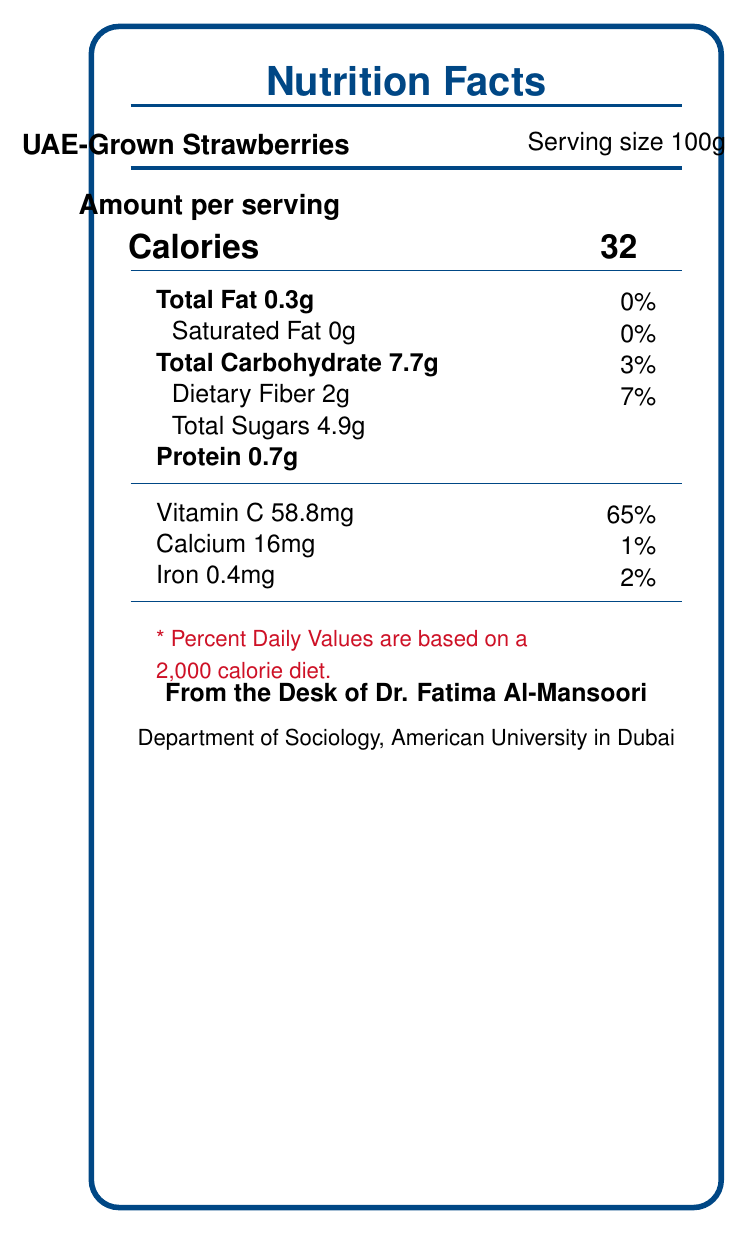what is the serving size for UAE-Grown Strawberries? The serving size for UAE-Grown Strawberries is clearly indicated at the top of the nutrition facts box as 100g.
Answer: 100g how many calories are there in a serving of UAE-Grown Strawberries? The number of calories per serving for UAE-Grown Strawberries is shown in bold in the middle of the nutrition facts box as 32 calories.
Answer: 32 calories what is the percentage of Daily Value for Vitamin C in UAE-Grown Strawberries? The percentage of Daily Value for Vitamin C is listed alongside the amount of Vitamin C (58.8mg) at the bottom of the nutrition facts box as 65%.
Answer: 65% what is the total carbohydrate content in UAE-Grown Strawberries? The total carbohydrate content is listed under the carbohydrate section in the nutrition facts box as 7.7g.
Answer: 7.7g what is the fiber content in a serving of UAE-Grown Strawberries? The amount of dietary fiber is specified under the carbohydrate section in the nutrition facts box as 2g.
Answer: 2g how much calcium is present in UAE-Grown Strawberries? The amount of calcium per serving is listed towards the bottom of the nutrition facts box as 16mg.
Answer: 16mg what is the total fat content in UAE-Grown Strawberries? The total fat content is given near the top of the nutrition facts box as 0.3g.
Answer: 0.3g what is the main focus of the nutrition facts document provided? The document is focused on providing detailed nutrition information for UAE-Grown Strawberries, including macronutrients, vitamins, and minerals per 100g serving.
Answer: Nutrition profile of UAE-Grown Strawberries which nutrient has the highest percentage of daily value in UAE-Grown Strawberries? A. Protein B. Vitamin C C. Iron D. Total Fat The document indicates that Vitamin C has the highest percentage of daily value at 65%.
Answer: B. Vitamin C how many grams of sugars are in UAE-Grown Strawberries? A. 2g B. 4.9g C. 7.7g D. 10g The total sugars in UAE-Grown Strawberries are listed in the nutrition facts box as 4.9g.
Answer: B. 4.9g are there any saturated fats in UAE-Grown Strawberries? The document states that the amount of saturated fat is 0g, indicating there are no saturated fats in UAE-Grown Strawberries.
Answer: No what other fruits or vegetables are compared in the study besides UAE-Grown Strawberries? The document provided only gives nutrition information for UAE-Grown Strawberries and does not list other fruits or vegetables compared in the study explicitly.
Answer: Not enough information 